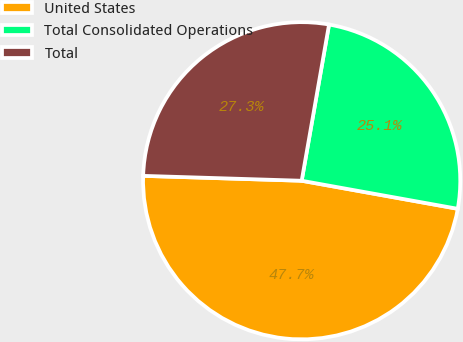Convert chart. <chart><loc_0><loc_0><loc_500><loc_500><pie_chart><fcel>United States<fcel>Total Consolidated Operations<fcel>Total<nl><fcel>47.66%<fcel>25.07%<fcel>27.27%<nl></chart> 